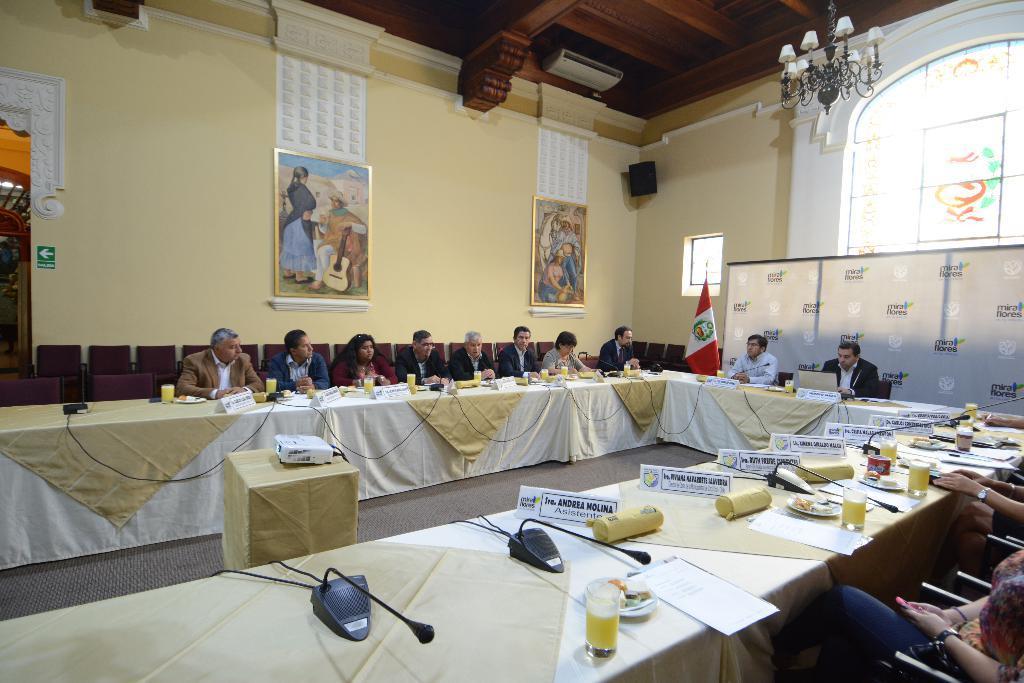How would you summarize this image in a sentence or two? In this image we can see many persons sitting at the table. On the table we can see glasses, papers, mics,name boards. On the left side of the image we can see projector placed on the table. In the background we can see chairs, flag, window, speaker, photo frames, stained glass, light, door and wall. 